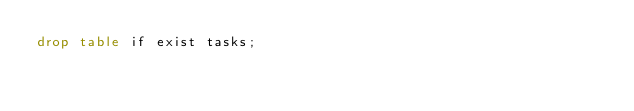Convert code to text. <code><loc_0><loc_0><loc_500><loc_500><_SQL_>drop table if exist tasks;
</code> 